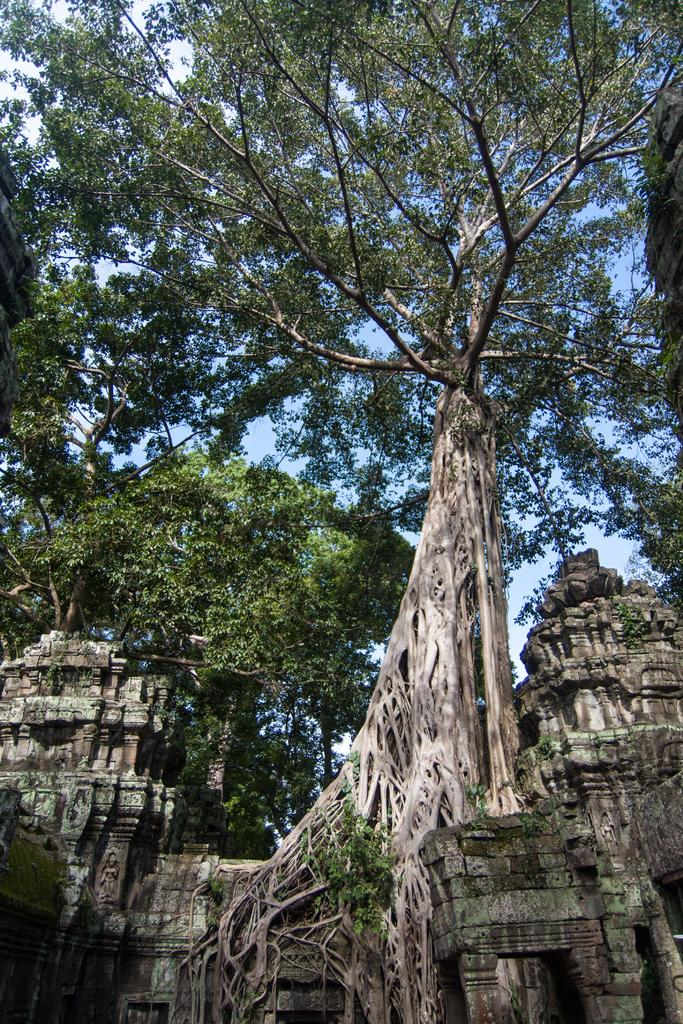What type of building is visible in the image? There is a temple in the image. What can be seen above the temple in the image? There are many trees above the temple in the image. How do the snails say good-bye to each other in the image? There are no snails present in the image, so it is not possible to answer that question. 